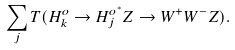<formula> <loc_0><loc_0><loc_500><loc_500>\sum _ { j } T ( H ^ { o } _ { k } \rightarrow H _ { j } ^ { o ^ { * } } Z \rightarrow W ^ { + } W ^ { - } Z ) .</formula> 